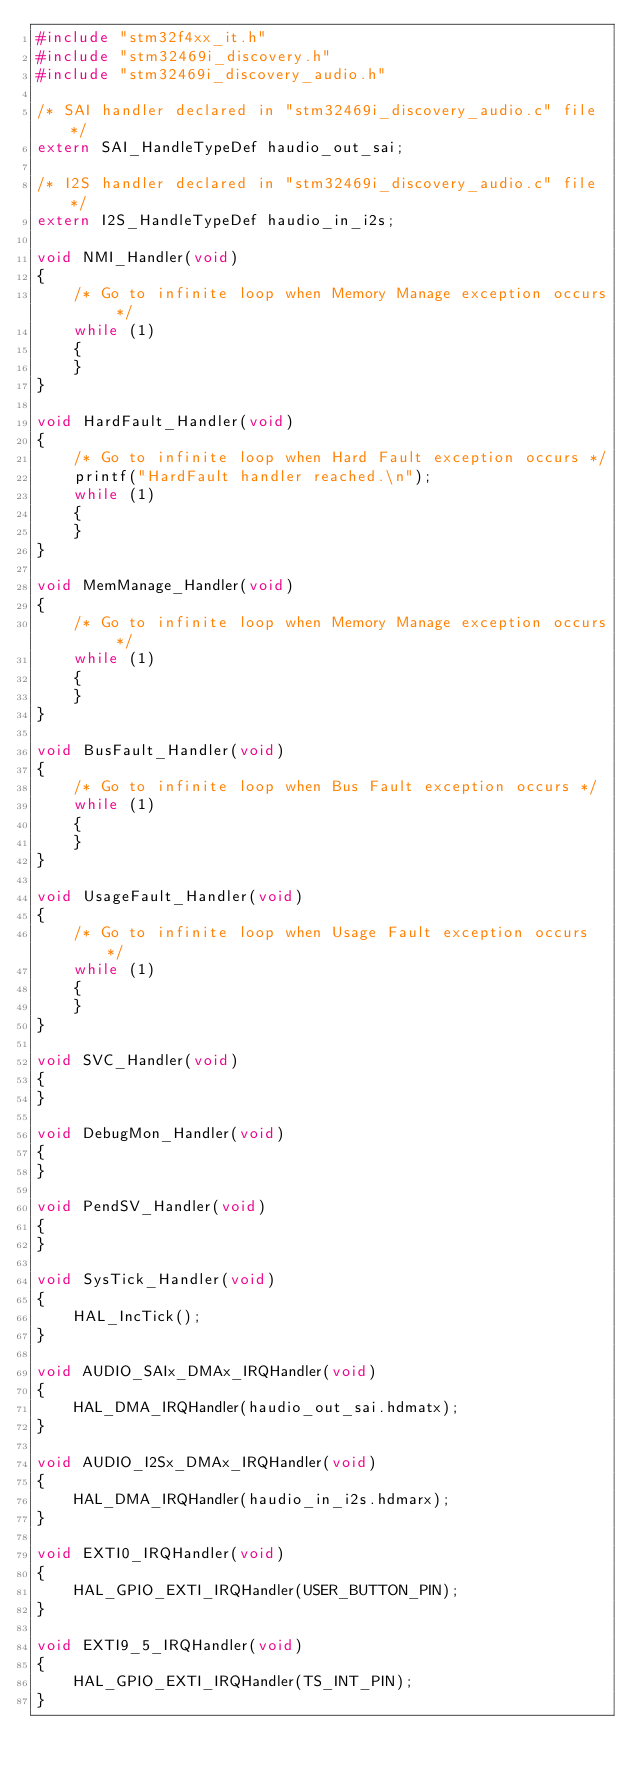<code> <loc_0><loc_0><loc_500><loc_500><_C_>#include "stm32f4xx_it.h"
#include "stm32469i_discovery.h"
#include "stm32469i_discovery_audio.h"

/* SAI handler declared in "stm32469i_discovery_audio.c" file */
extern SAI_HandleTypeDef haudio_out_sai;

/* I2S handler declared in "stm32469i_discovery_audio.c" file */
extern I2S_HandleTypeDef haudio_in_i2s;

void NMI_Handler(void)
{
	/* Go to infinite loop when Memory Manage exception occurs */
	while (1)
	{
	}
}

void HardFault_Handler(void)
{
	/* Go to infinite loop when Hard Fault exception occurs */
	printf("HardFault handler reached.\n");
	while (1)
	{
	}
}

void MemManage_Handler(void)
{
	/* Go to infinite loop when Memory Manage exception occurs */
	while (1)
	{
	}
}

void BusFault_Handler(void)
{
	/* Go to infinite loop when Bus Fault exception occurs */
	while (1)
	{
	}
}

void UsageFault_Handler(void)
{
	/* Go to infinite loop when Usage Fault exception occurs */
	while (1)
	{
	}
}

void SVC_Handler(void)
{
}

void DebugMon_Handler(void)
{
}

void PendSV_Handler(void)
{
}

void SysTick_Handler(void)
{
	HAL_IncTick();
}

void AUDIO_SAIx_DMAx_IRQHandler(void)
{
	HAL_DMA_IRQHandler(haudio_out_sai.hdmatx);
}

void AUDIO_I2Sx_DMAx_IRQHandler(void)
{
	HAL_DMA_IRQHandler(haudio_in_i2s.hdmarx);
}

void EXTI0_IRQHandler(void)
{
	HAL_GPIO_EXTI_IRQHandler(USER_BUTTON_PIN);
}

void EXTI9_5_IRQHandler(void)
{
	HAL_GPIO_EXTI_IRQHandler(TS_INT_PIN);
}
</code> 